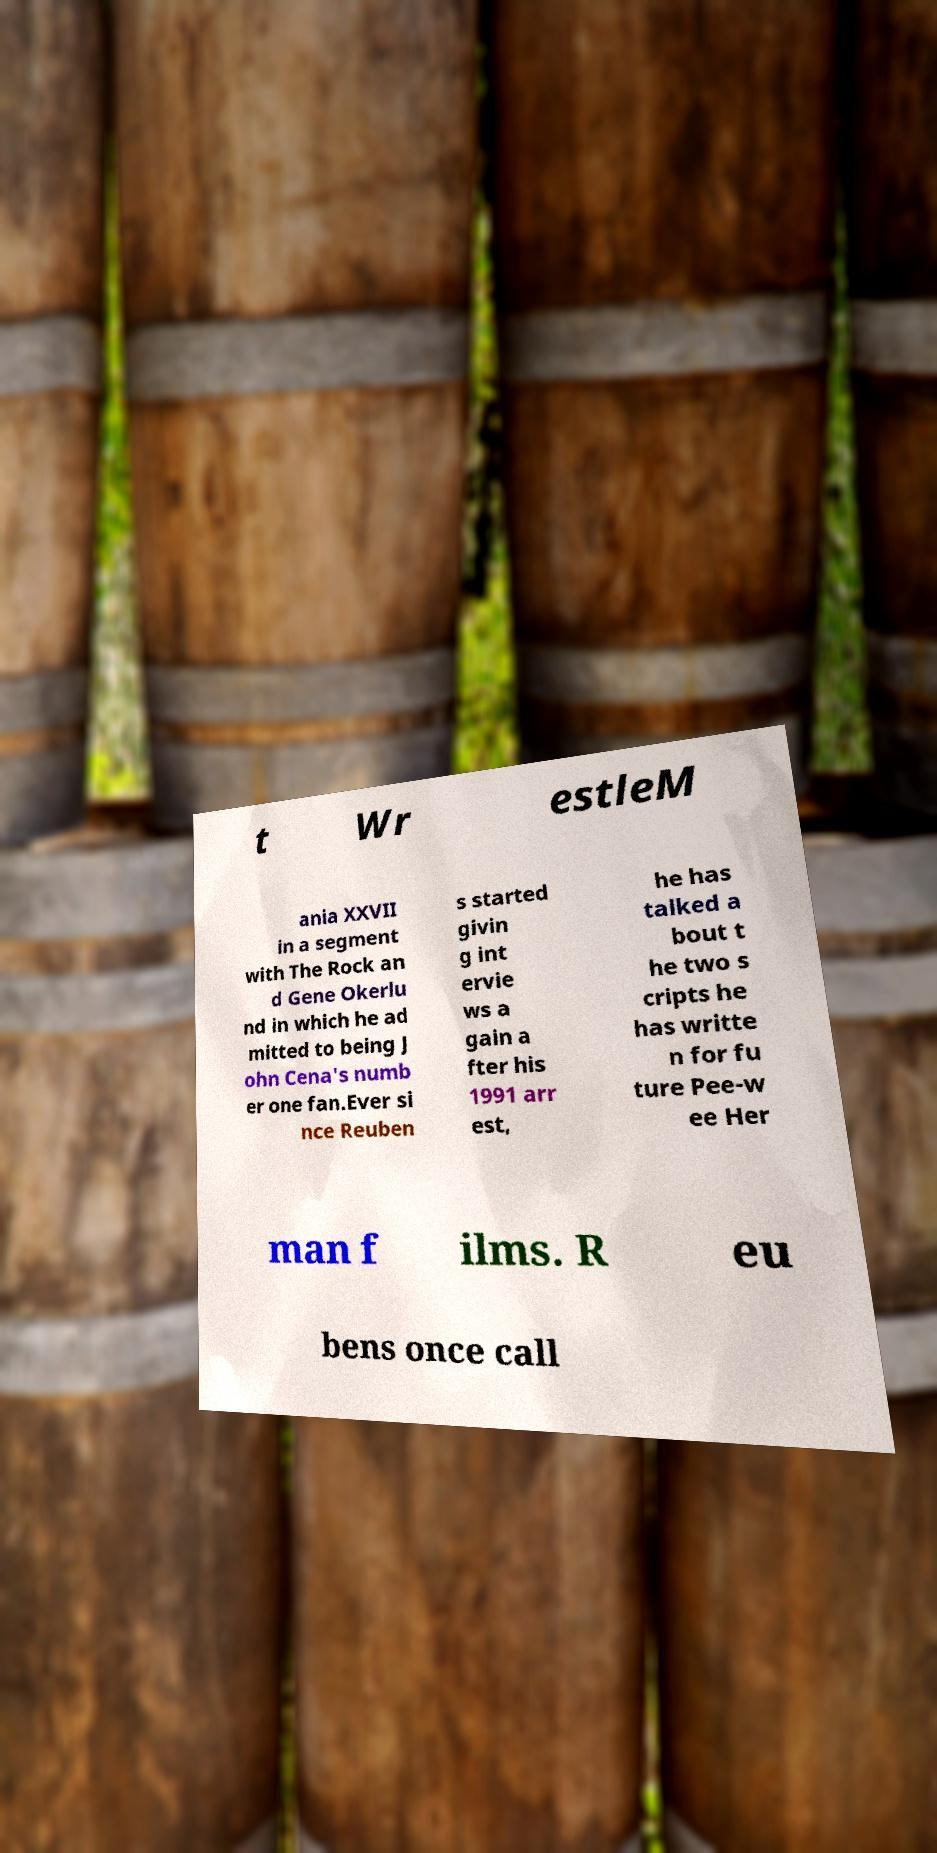What messages or text are displayed in this image? I need them in a readable, typed format. t Wr estleM ania XXVII in a segment with The Rock an d Gene Okerlu nd in which he ad mitted to being J ohn Cena's numb er one fan.Ever si nce Reuben s started givin g int ervie ws a gain a fter his 1991 arr est, he has talked a bout t he two s cripts he has writte n for fu ture Pee-w ee Her man f ilms. R eu bens once call 